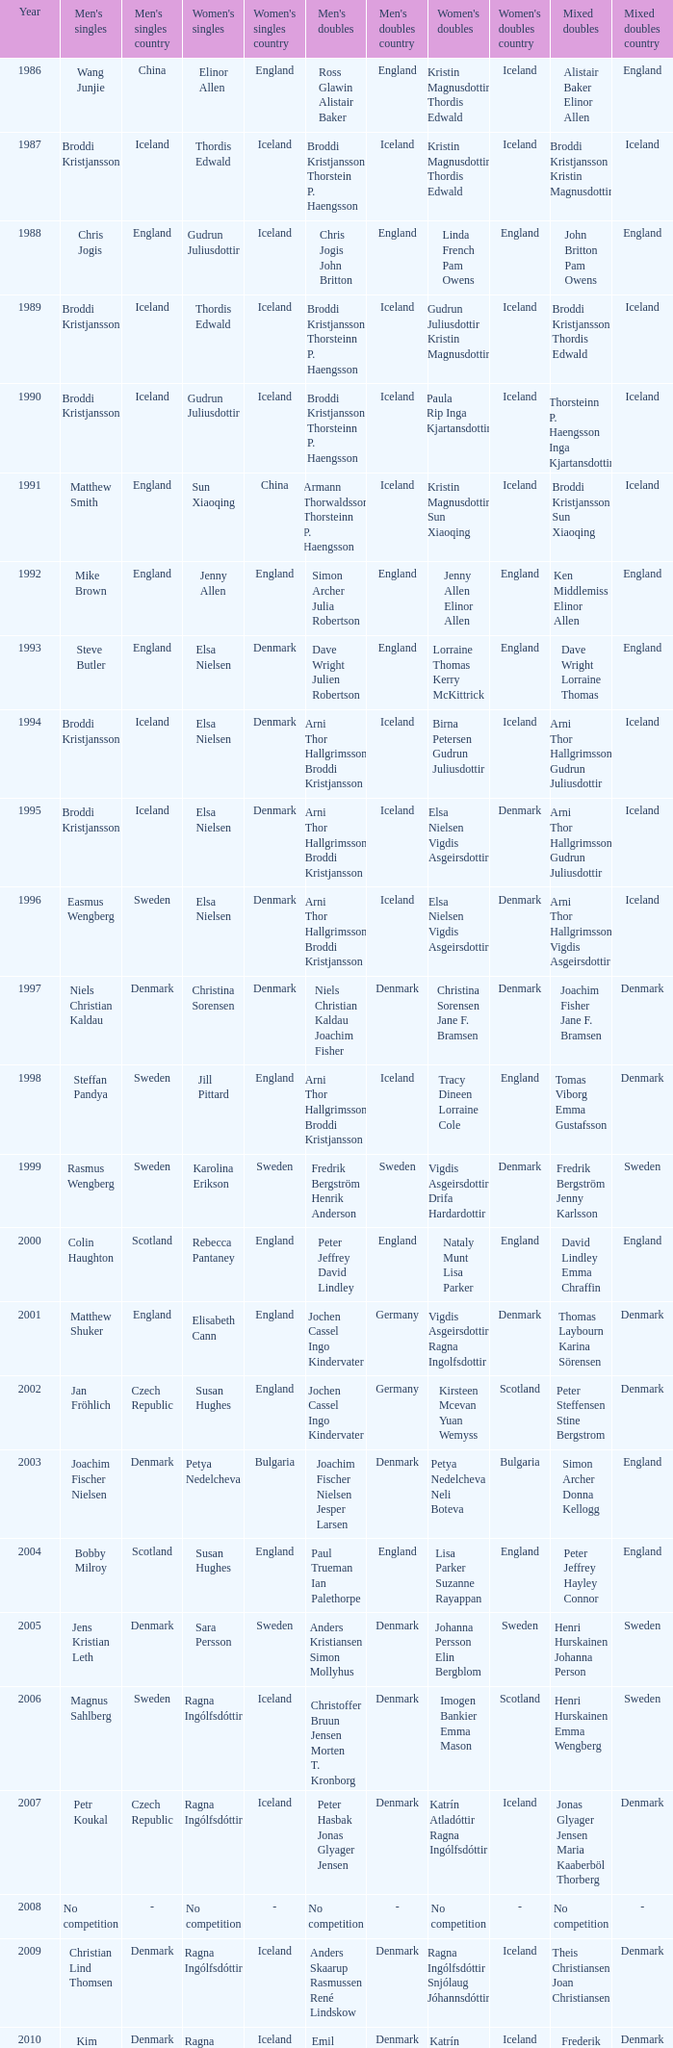In what mixed doubles did Niels Christian Kaldau play in men's singles? Joachim Fisher Jane F. Bramsen. 